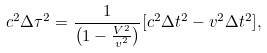<formula> <loc_0><loc_0><loc_500><loc_500>c ^ { 2 } \Delta \tau ^ { 2 } = \frac { 1 } { \left ( 1 - \frac { V ^ { 2 } } { v ^ { 2 } } \right ) } [ c ^ { 2 } \Delta t ^ { 2 } - v ^ { 2 } \Delta t ^ { 2 } ] ,</formula> 